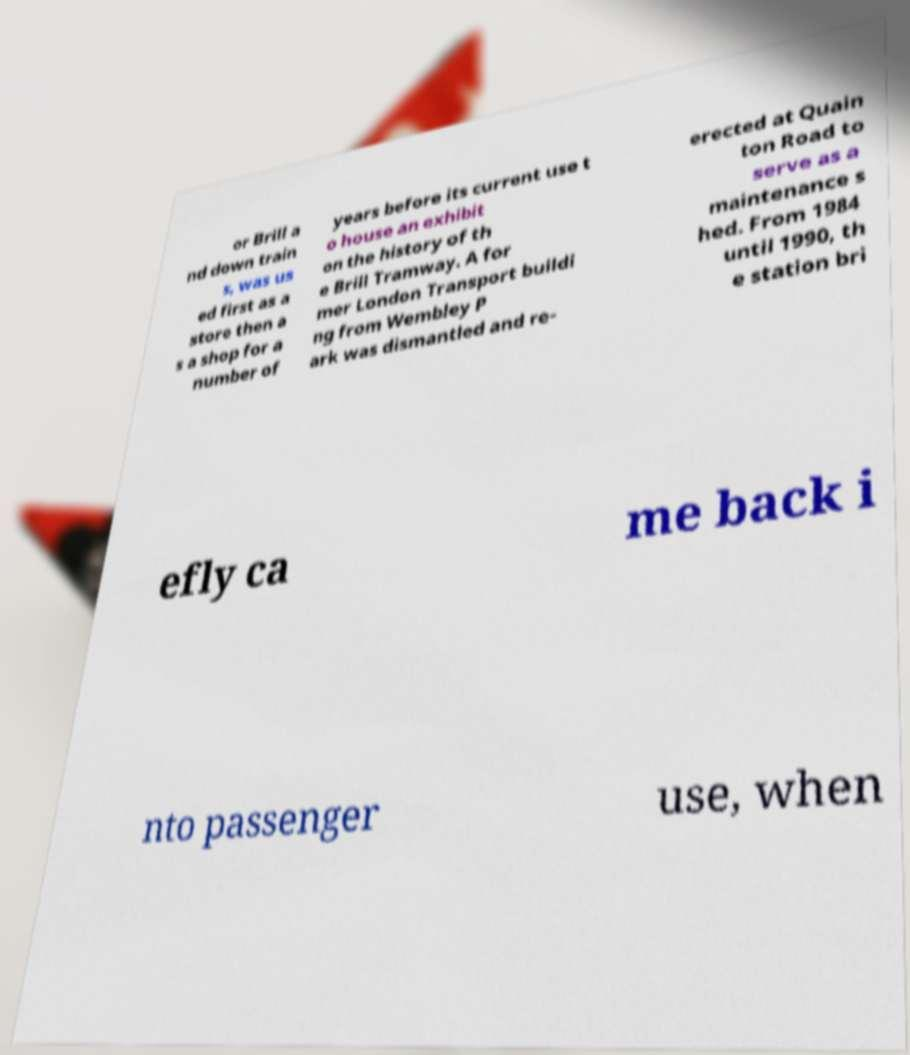For documentation purposes, I need the text within this image transcribed. Could you provide that? or Brill a nd down train s, was us ed first as a store then a s a shop for a number of years before its current use t o house an exhibit on the history of th e Brill Tramway. A for mer London Transport buildi ng from Wembley P ark was dismantled and re- erected at Quain ton Road to serve as a maintenance s hed. From 1984 until 1990, th e station bri efly ca me back i nto passenger use, when 